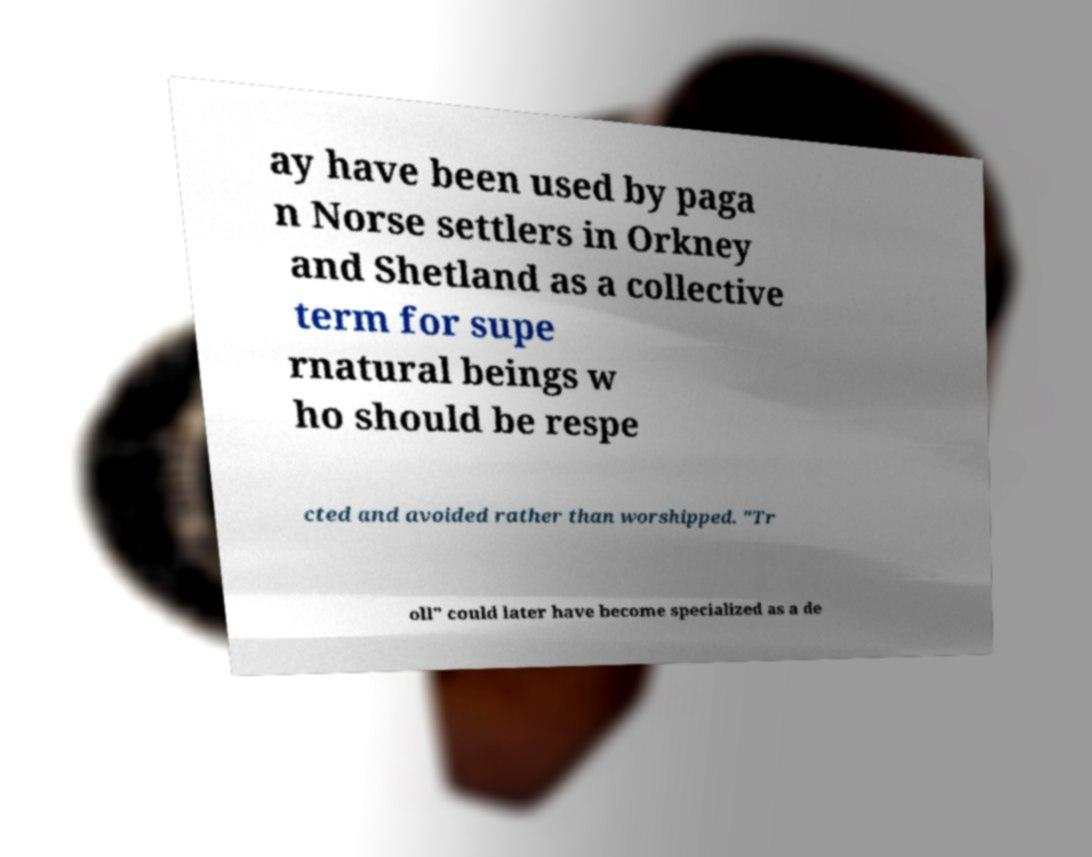I need the written content from this picture converted into text. Can you do that? ay have been used by paga n Norse settlers in Orkney and Shetland as a collective term for supe rnatural beings w ho should be respe cted and avoided rather than worshipped. "Tr oll" could later have become specialized as a de 